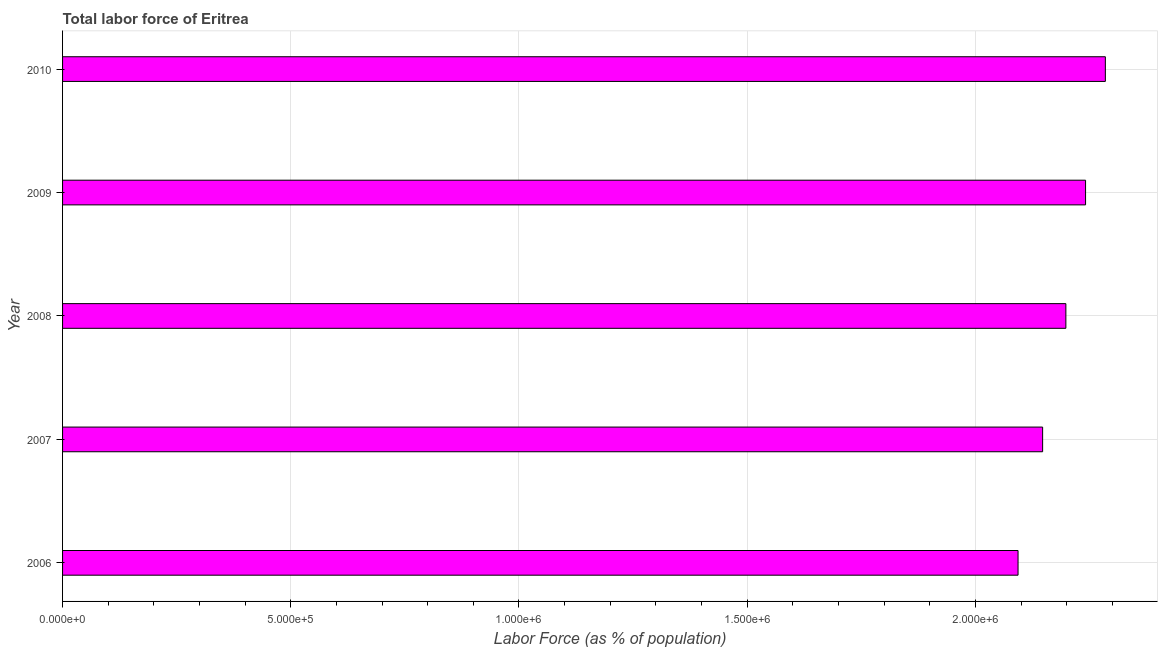Does the graph contain any zero values?
Give a very brief answer. No. What is the title of the graph?
Ensure brevity in your answer.  Total labor force of Eritrea. What is the label or title of the X-axis?
Give a very brief answer. Labor Force (as % of population). What is the label or title of the Y-axis?
Your answer should be compact. Year. What is the total labor force in 2010?
Your answer should be very brief. 2.28e+06. Across all years, what is the maximum total labor force?
Make the answer very short. 2.28e+06. Across all years, what is the minimum total labor force?
Your answer should be compact. 2.09e+06. What is the sum of the total labor force?
Your response must be concise. 1.10e+07. What is the difference between the total labor force in 2006 and 2010?
Make the answer very short. -1.91e+05. What is the average total labor force per year?
Give a very brief answer. 2.19e+06. What is the median total labor force?
Your response must be concise. 2.20e+06. What is the ratio of the total labor force in 2006 to that in 2010?
Your response must be concise. 0.92. What is the difference between the highest and the second highest total labor force?
Your answer should be very brief. 4.34e+04. What is the difference between the highest and the lowest total labor force?
Provide a short and direct response. 1.91e+05. How many bars are there?
Your response must be concise. 5. Are all the bars in the graph horizontal?
Your response must be concise. Yes. How many years are there in the graph?
Your response must be concise. 5. What is the Labor Force (as % of population) of 2006?
Your answer should be compact. 2.09e+06. What is the Labor Force (as % of population) in 2007?
Your response must be concise. 2.15e+06. What is the Labor Force (as % of population) of 2008?
Provide a succinct answer. 2.20e+06. What is the Labor Force (as % of population) in 2009?
Provide a short and direct response. 2.24e+06. What is the Labor Force (as % of population) of 2010?
Offer a very short reply. 2.28e+06. What is the difference between the Labor Force (as % of population) in 2006 and 2007?
Provide a short and direct response. -5.38e+04. What is the difference between the Labor Force (as % of population) in 2006 and 2008?
Your answer should be compact. -1.05e+05. What is the difference between the Labor Force (as % of population) in 2006 and 2009?
Make the answer very short. -1.48e+05. What is the difference between the Labor Force (as % of population) in 2006 and 2010?
Make the answer very short. -1.91e+05. What is the difference between the Labor Force (as % of population) in 2007 and 2008?
Keep it short and to the point. -5.09e+04. What is the difference between the Labor Force (as % of population) in 2007 and 2009?
Your response must be concise. -9.41e+04. What is the difference between the Labor Force (as % of population) in 2007 and 2010?
Ensure brevity in your answer.  -1.37e+05. What is the difference between the Labor Force (as % of population) in 2008 and 2009?
Make the answer very short. -4.31e+04. What is the difference between the Labor Force (as % of population) in 2008 and 2010?
Provide a succinct answer. -8.65e+04. What is the difference between the Labor Force (as % of population) in 2009 and 2010?
Provide a succinct answer. -4.34e+04. What is the ratio of the Labor Force (as % of population) in 2006 to that in 2008?
Provide a succinct answer. 0.95. What is the ratio of the Labor Force (as % of population) in 2006 to that in 2009?
Your answer should be very brief. 0.93. What is the ratio of the Labor Force (as % of population) in 2006 to that in 2010?
Your answer should be very brief. 0.92. What is the ratio of the Labor Force (as % of population) in 2007 to that in 2008?
Ensure brevity in your answer.  0.98. What is the ratio of the Labor Force (as % of population) in 2007 to that in 2009?
Offer a very short reply. 0.96. What is the ratio of the Labor Force (as % of population) in 2008 to that in 2010?
Offer a terse response. 0.96. What is the ratio of the Labor Force (as % of population) in 2009 to that in 2010?
Ensure brevity in your answer.  0.98. 